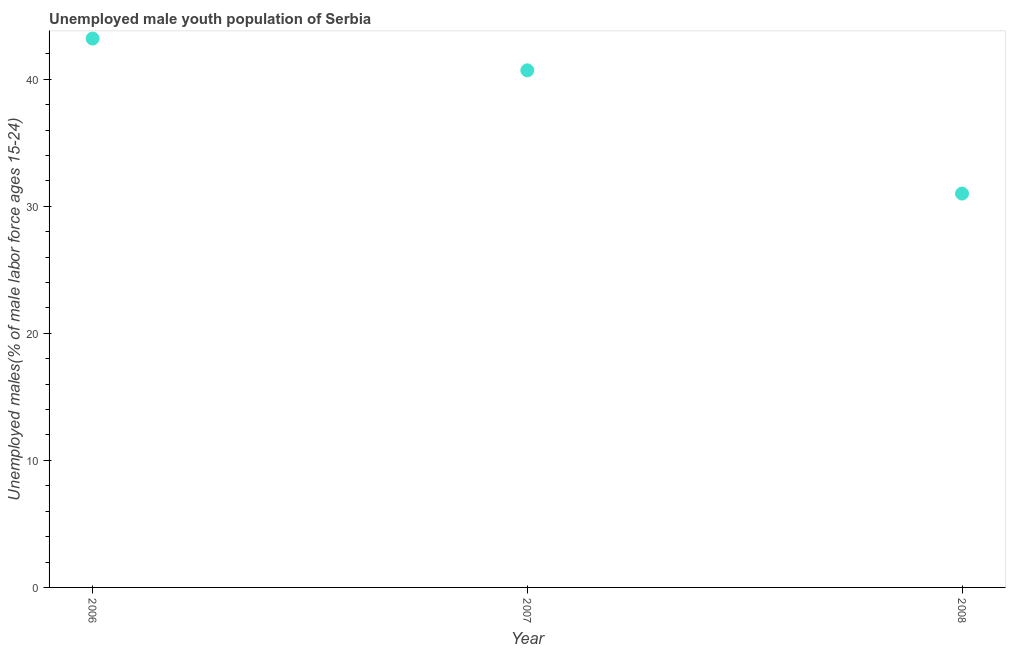What is the unemployed male youth in 2006?
Ensure brevity in your answer.  43.2. Across all years, what is the maximum unemployed male youth?
Provide a short and direct response. 43.2. In which year was the unemployed male youth maximum?
Your response must be concise. 2006. In which year was the unemployed male youth minimum?
Your answer should be very brief. 2008. What is the sum of the unemployed male youth?
Your response must be concise. 114.9. What is the average unemployed male youth per year?
Keep it short and to the point. 38.3. What is the median unemployed male youth?
Provide a short and direct response. 40.7. In how many years, is the unemployed male youth greater than 40 %?
Offer a terse response. 2. Do a majority of the years between 2006 and 2008 (inclusive) have unemployed male youth greater than 34 %?
Your answer should be very brief. Yes. What is the ratio of the unemployed male youth in 2006 to that in 2008?
Give a very brief answer. 1.39. Is the difference between the unemployed male youth in 2006 and 2008 greater than the difference between any two years?
Provide a succinct answer. Yes. What is the difference between the highest and the lowest unemployed male youth?
Offer a very short reply. 12.2. In how many years, is the unemployed male youth greater than the average unemployed male youth taken over all years?
Give a very brief answer. 2. Does the graph contain any zero values?
Provide a short and direct response. No. What is the title of the graph?
Make the answer very short. Unemployed male youth population of Serbia. What is the label or title of the Y-axis?
Offer a very short reply. Unemployed males(% of male labor force ages 15-24). What is the Unemployed males(% of male labor force ages 15-24) in 2006?
Make the answer very short. 43.2. What is the Unemployed males(% of male labor force ages 15-24) in 2007?
Provide a succinct answer. 40.7. What is the difference between the Unemployed males(% of male labor force ages 15-24) in 2006 and 2007?
Ensure brevity in your answer.  2.5. What is the difference between the Unemployed males(% of male labor force ages 15-24) in 2006 and 2008?
Your response must be concise. 12.2. What is the ratio of the Unemployed males(% of male labor force ages 15-24) in 2006 to that in 2007?
Your response must be concise. 1.06. What is the ratio of the Unemployed males(% of male labor force ages 15-24) in 2006 to that in 2008?
Offer a terse response. 1.39. What is the ratio of the Unemployed males(% of male labor force ages 15-24) in 2007 to that in 2008?
Give a very brief answer. 1.31. 